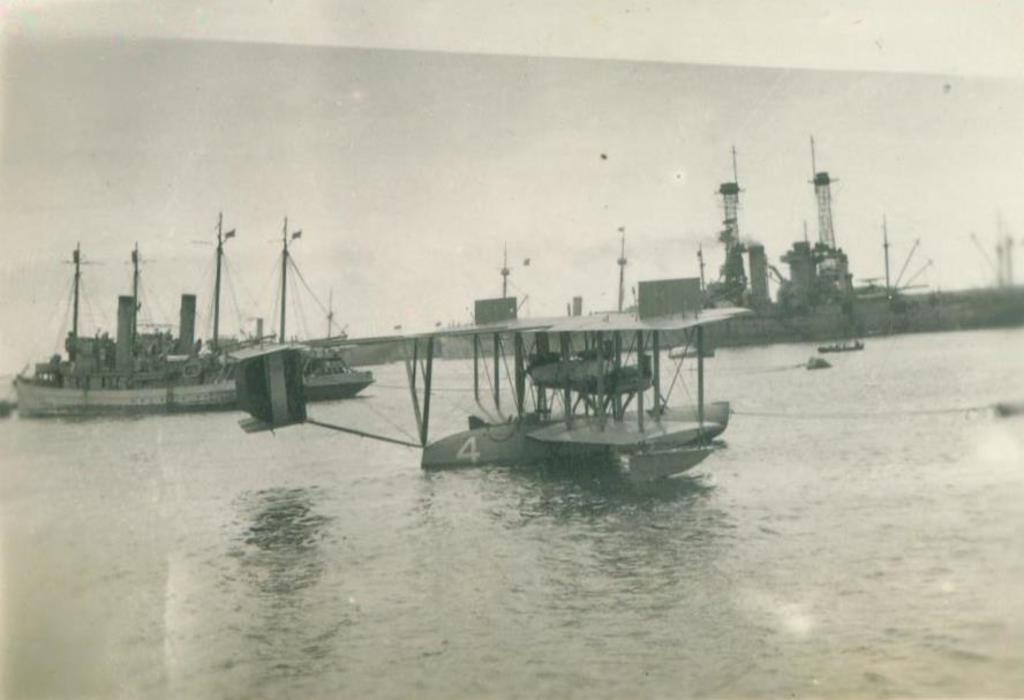What is the main subject of the image? The main subject of the image is ships. Where are the ships located in the image? The ships are on the water. What is the color scheme of the image? The photography is in black and white. What example of quicksand can be seen in the image? There is no example of quicksand present in the image; it features ships on the water. 